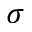Convert formula to latex. <formula><loc_0><loc_0><loc_500><loc_500>\sigma</formula> 